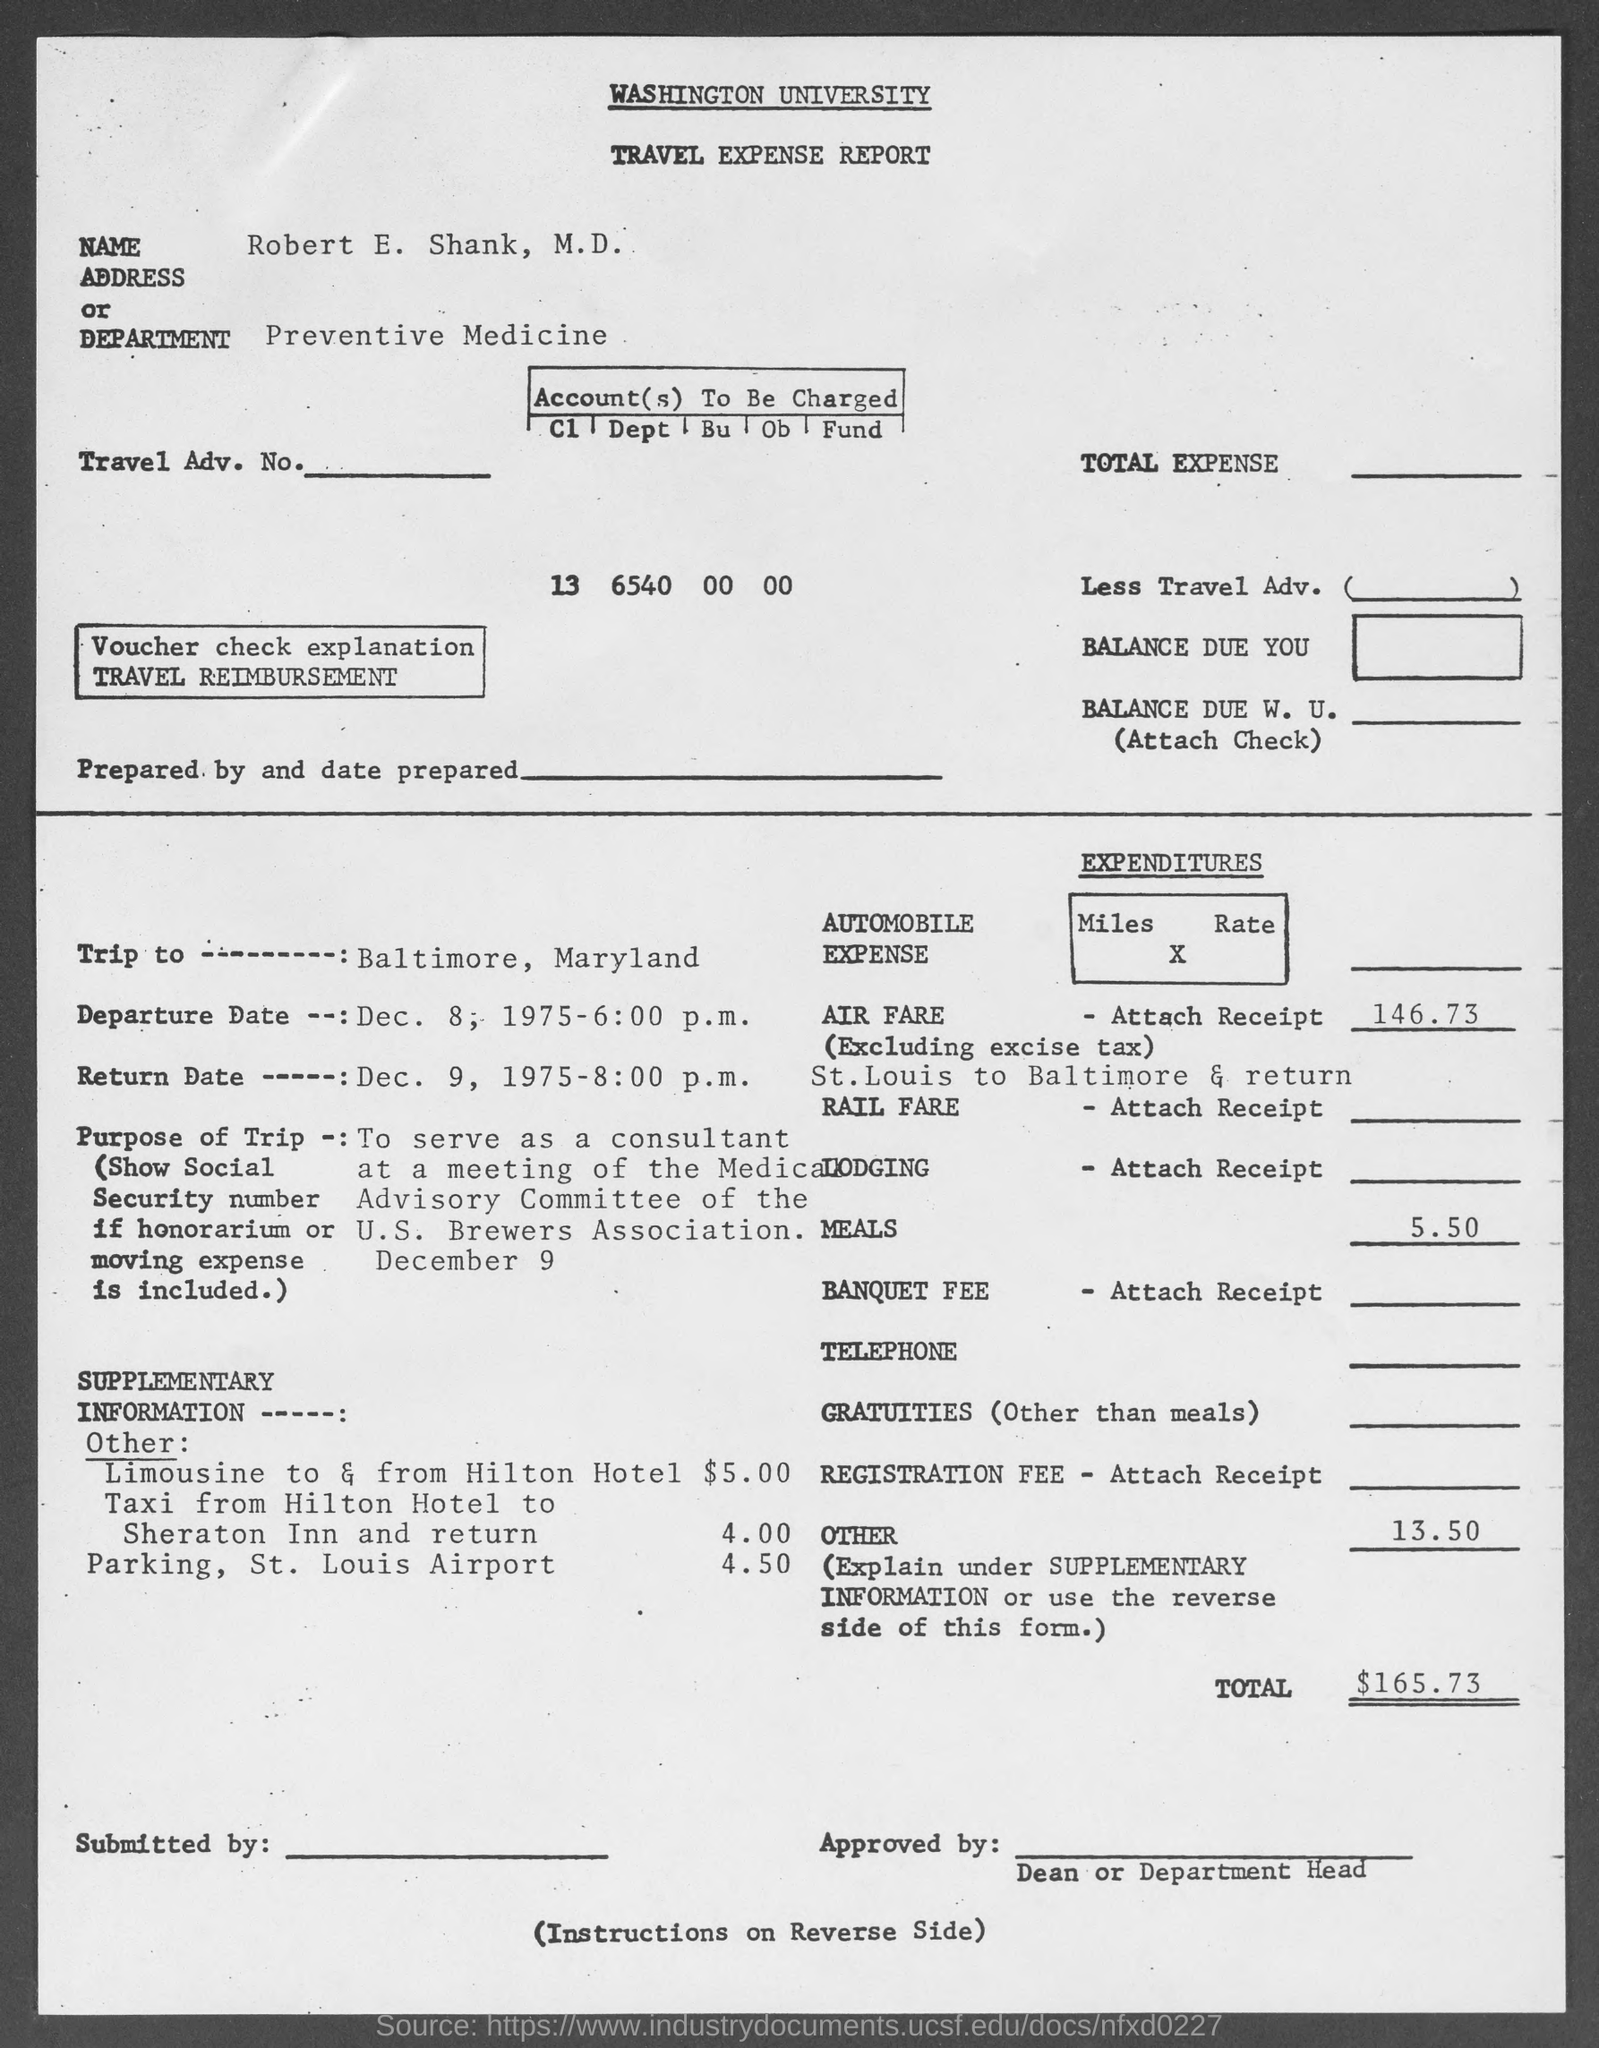What is written in the top of the document ?
Make the answer very short. WASHINGTON  UNIVERSITY. Who's Name written in the Name field ?
Your answer should be compact. Robert E. Shank, M.D. What is the Department Name  ?
Keep it short and to the point. Preventive Medicine. How much Total Expenditure ?
Your response must be concise. $165.73. 